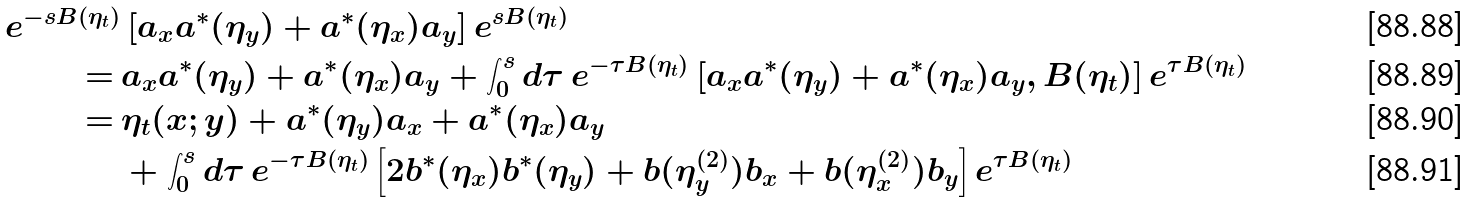<formula> <loc_0><loc_0><loc_500><loc_500>e ^ { - s B ( \eta _ { t } ) } & \left [ a _ { x } a ^ { * } ( \eta _ { y } ) + a ^ { * } ( \eta _ { x } ) a _ { y } \right ] e ^ { s B ( \eta _ { t } ) } \\ = \, & a _ { x } a ^ { * } ( \eta _ { y } ) + a ^ { * } ( \eta _ { x } ) a _ { y } + \int _ { 0 } ^ { s } d \tau \, e ^ { - \tau B ( \eta _ { t } ) } \left [ a _ { x } a ^ { * } ( \eta _ { y } ) + a ^ { * } ( \eta _ { x } ) a _ { y } , B ( \eta _ { t } ) \right ] e ^ { \tau B ( \eta _ { t } ) } \\ = \, & \eta _ { t } ( x ; y ) + a ^ { * } ( \eta _ { y } ) a _ { x } + a ^ { * } ( \eta _ { x } ) a _ { y } \\ & + \int _ { 0 } ^ { s } d \tau \, e ^ { - \tau B ( \eta _ { t } ) } \left [ 2 b ^ { * } ( \eta _ { x } ) b ^ { * } ( \eta _ { y } ) + b ( \eta ^ { ( 2 ) } _ { y } ) b _ { x } + b ( \eta ^ { ( 2 ) } _ { x } ) b _ { y } \right ] e ^ { \tau B ( \eta _ { t } ) }</formula> 